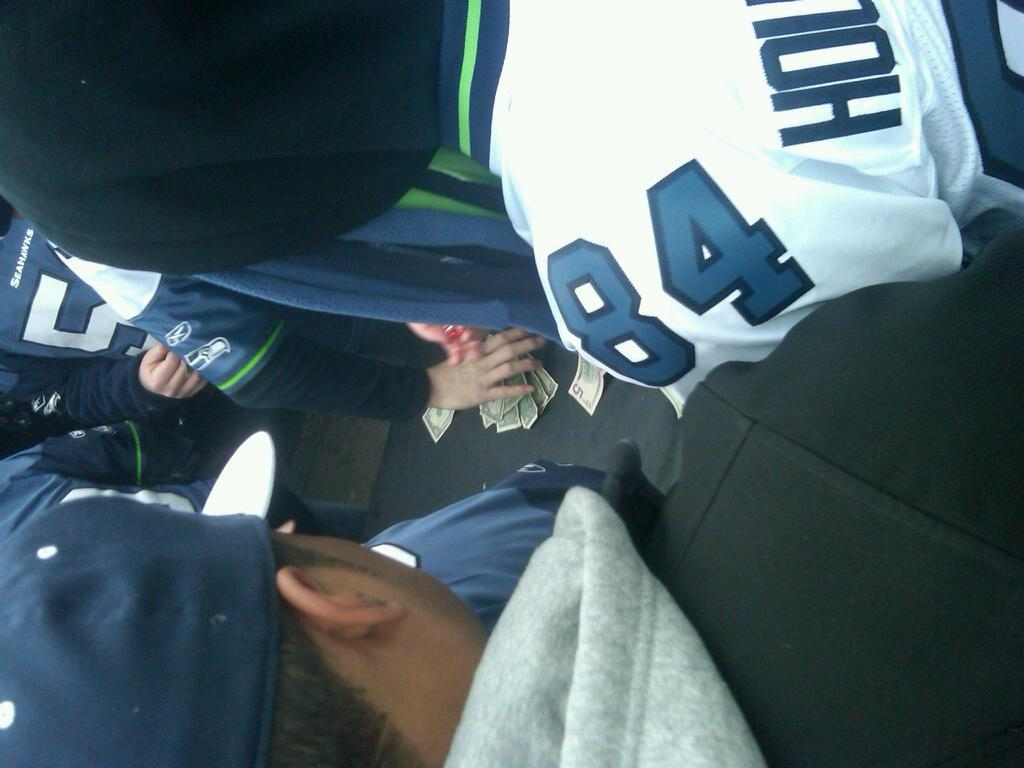How many people are in the image? There are people in the image, but the exact number is not specified. What colors are the dresses worn by the people in the image? The people are wearing blue, white, black, and ash-colored dresses. Can you describe any specific body part visible in the image? A person's hand is visible in the image. What is present in the image that might be related to financial transactions? Money is present in the image. Can you tell me how many goldfish are swimming in the image? There are no goldfish present in the image. What type of ant can be seen crawling on the person's hand in the image? There are no ants visible in the image, and the person's hand is not described in enough detail to determine the presence of ants. 